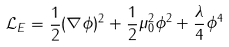Convert formula to latex. <formula><loc_0><loc_0><loc_500><loc_500>\mathcal { L } _ { E } = \frac { 1 } { 2 } ( \nabla \phi ) ^ { 2 } + \frac { 1 } { 2 } \mu _ { 0 } ^ { 2 } \phi ^ { 2 } + \frac { \lambda } { 4 } \phi ^ { 4 }</formula> 